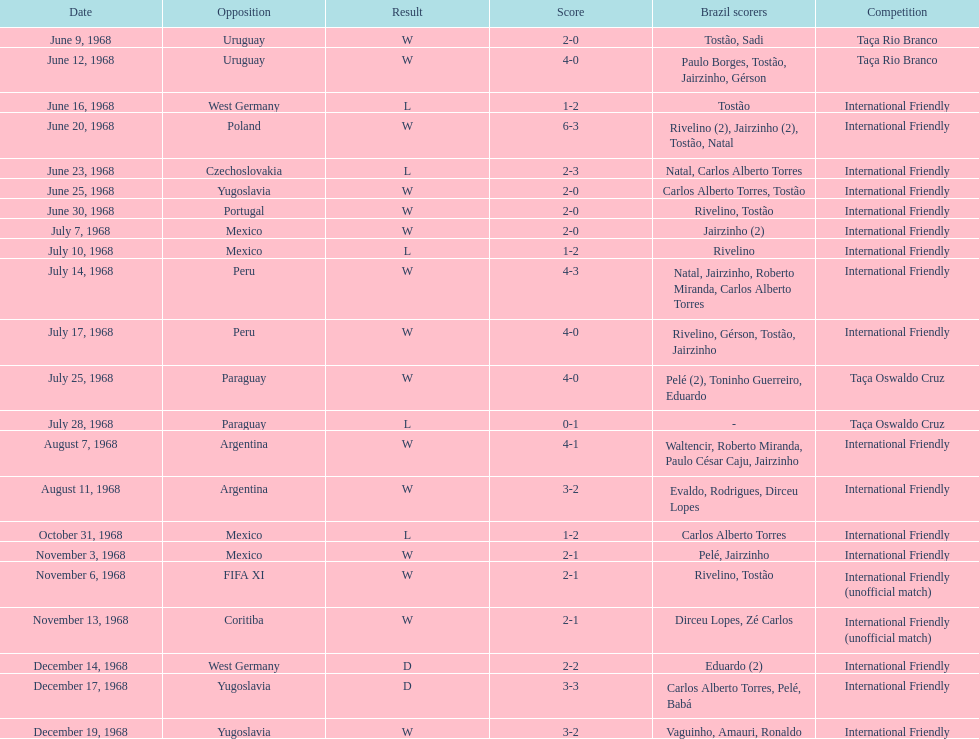How many goals did brazil make during the game on november 6th? 2. 